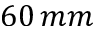<formula> <loc_0><loc_0><loc_500><loc_500>6 0 \, m m</formula> 